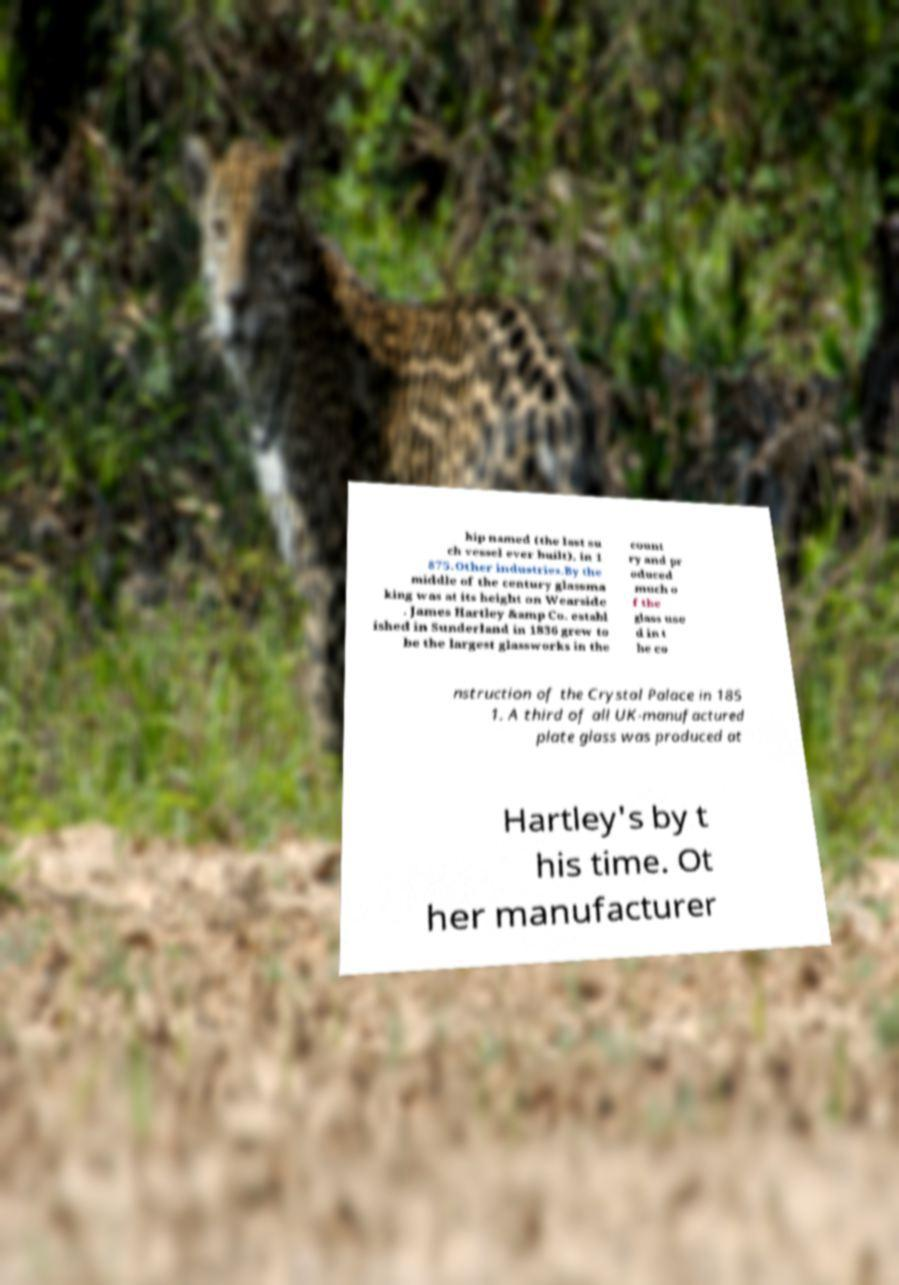Can you accurately transcribe the text from the provided image for me? hip named (the last su ch vessel ever built), in 1 875.Other industries.By the middle of the century glassma king was at its height on Wearside . James Hartley &amp Co. establ ished in Sunderland in 1836 grew to be the largest glassworks in the count ry and pr oduced much o f the glass use d in t he co nstruction of the Crystal Palace in 185 1. A third of all UK-manufactured plate glass was produced at Hartley's by t his time. Ot her manufacturer 